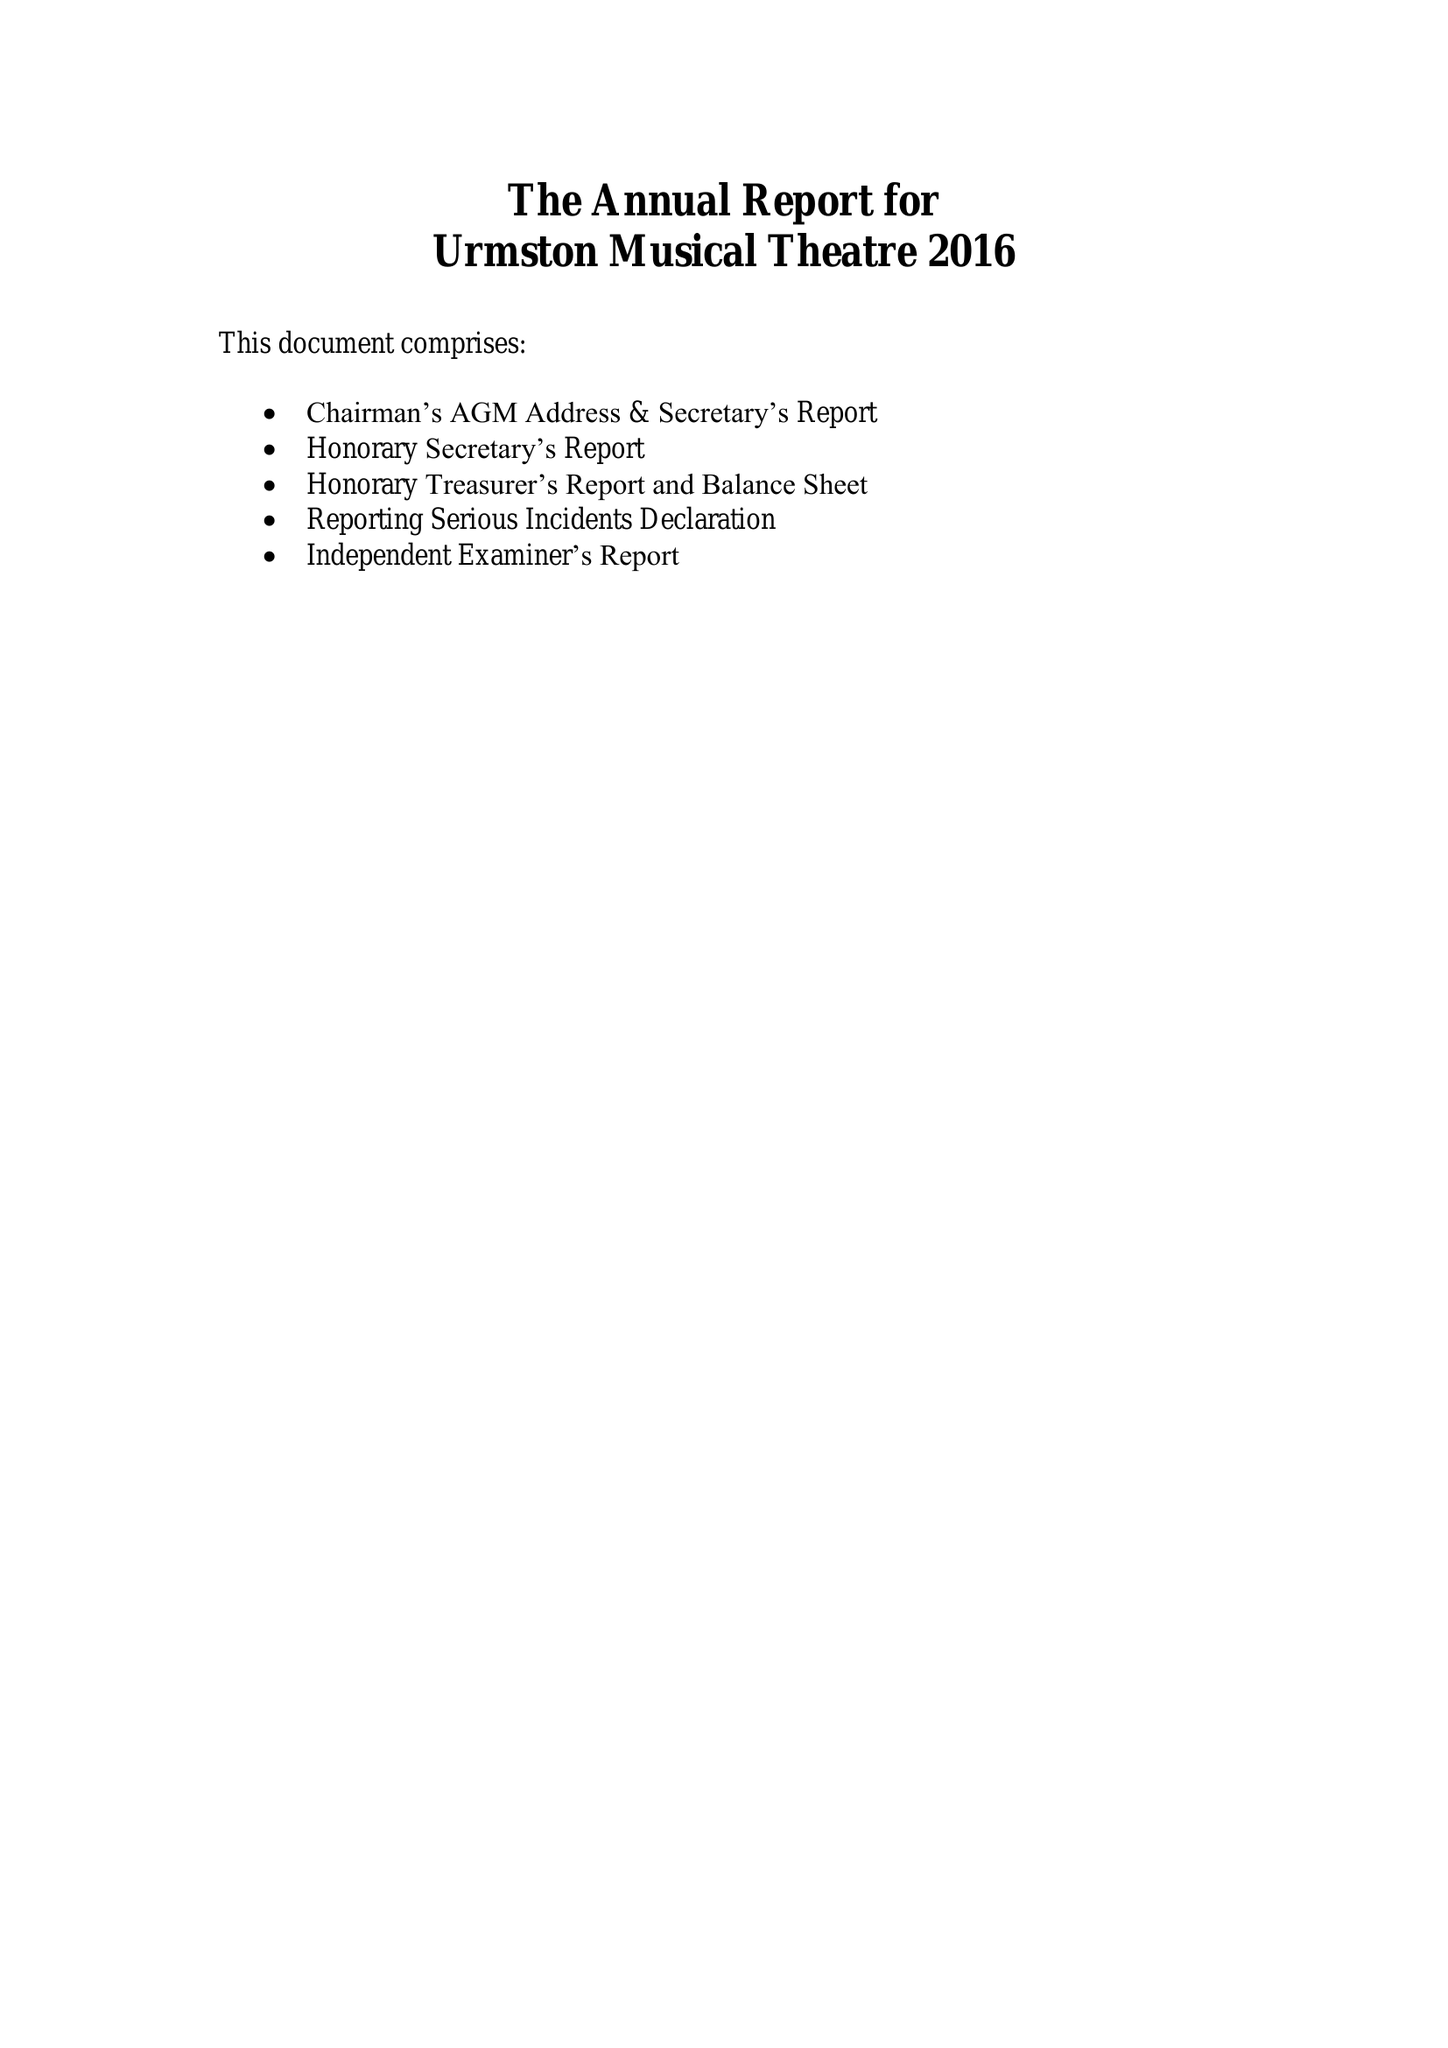What is the value for the address__street_line?
Answer the question using a single word or phrase. 41 PRINCESS ROAD 